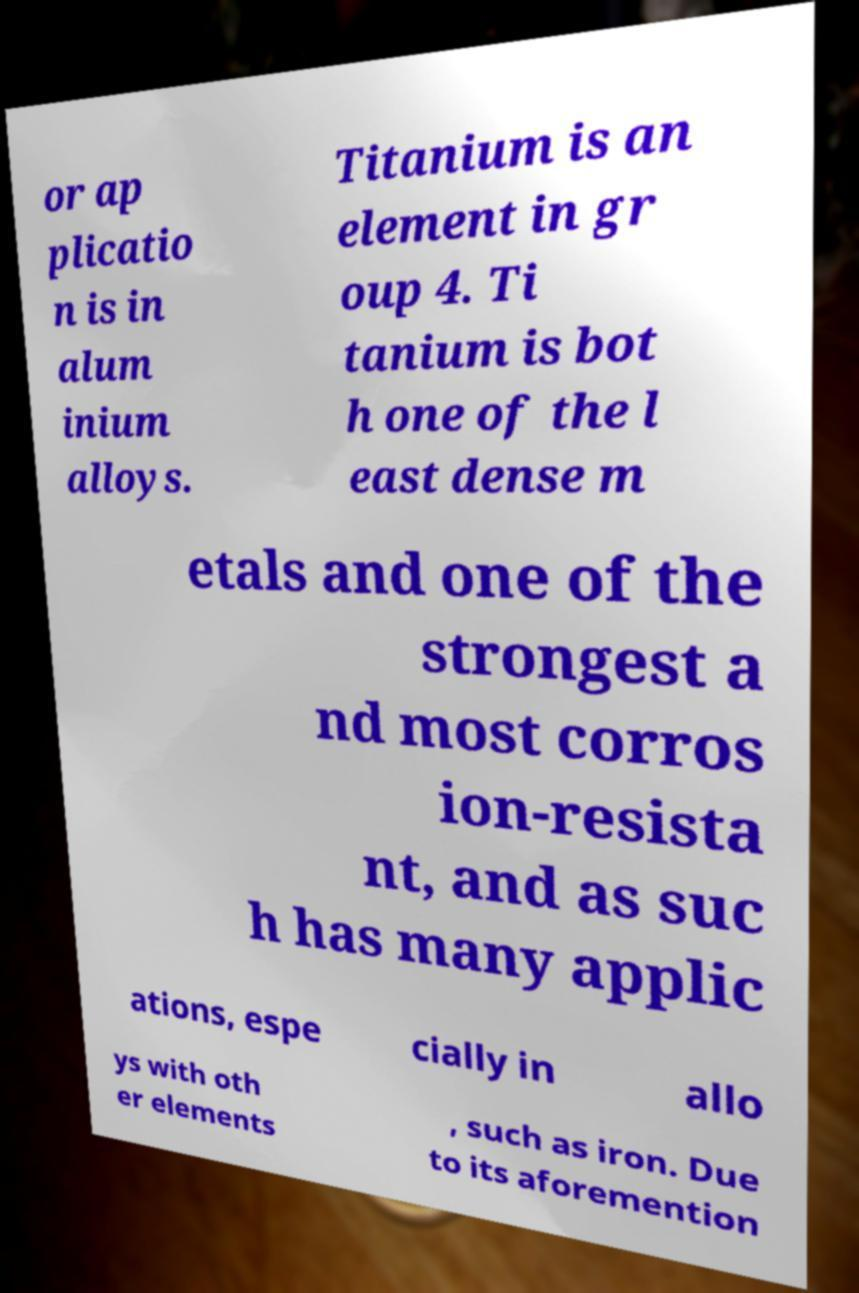I need the written content from this picture converted into text. Can you do that? or ap plicatio n is in alum inium alloys. Titanium is an element in gr oup 4. Ti tanium is bot h one of the l east dense m etals and one of the strongest a nd most corros ion-resista nt, and as suc h has many applic ations, espe cially in allo ys with oth er elements , such as iron. Due to its aforemention 